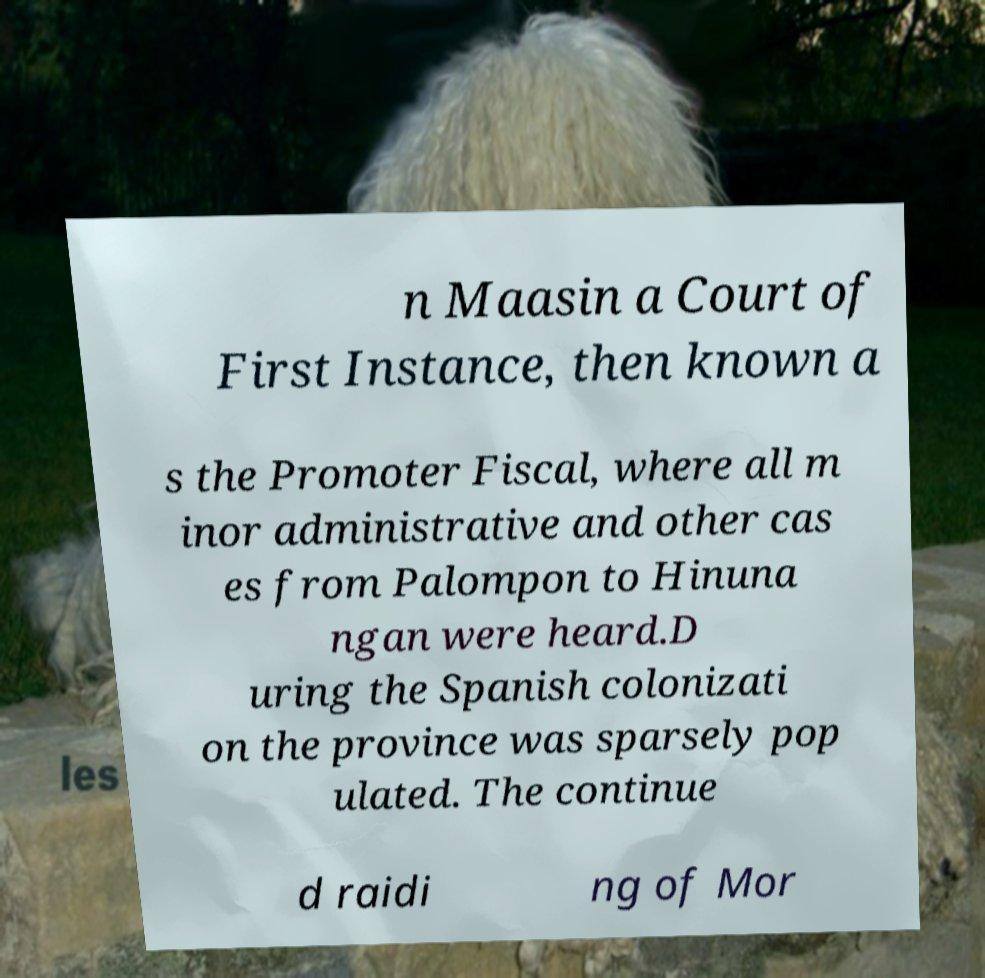Can you read and provide the text displayed in the image?This photo seems to have some interesting text. Can you extract and type it out for me? n Maasin a Court of First Instance, then known a s the Promoter Fiscal, where all m inor administrative and other cas es from Palompon to Hinuna ngan were heard.D uring the Spanish colonizati on the province was sparsely pop ulated. The continue d raidi ng of Mor 